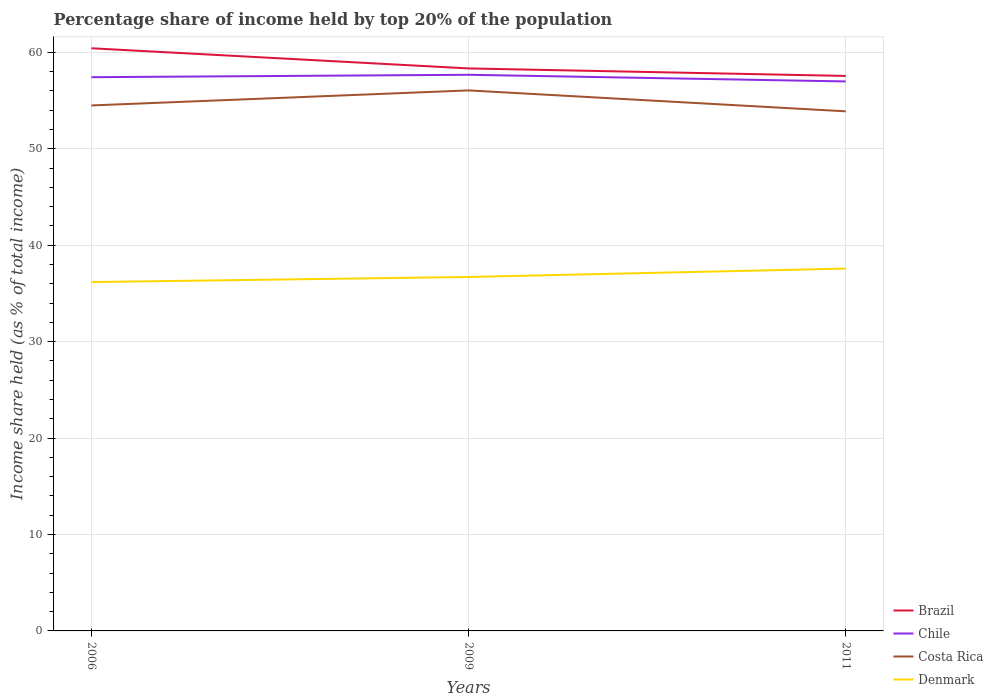How many different coloured lines are there?
Give a very brief answer. 4. Is the number of lines equal to the number of legend labels?
Offer a very short reply. Yes. Across all years, what is the maximum percentage share of income held by top 20% of the population in Chile?
Provide a short and direct response. 56.99. What is the total percentage share of income held by top 20% of the population in Brazil in the graph?
Offer a terse response. 0.78. What is the difference between the highest and the second highest percentage share of income held by top 20% of the population in Costa Rica?
Offer a terse response. 2.17. Are the values on the major ticks of Y-axis written in scientific E-notation?
Give a very brief answer. No. How many legend labels are there?
Provide a short and direct response. 4. How are the legend labels stacked?
Make the answer very short. Vertical. What is the title of the graph?
Provide a succinct answer. Percentage share of income held by top 20% of the population. Does "Macao" appear as one of the legend labels in the graph?
Keep it short and to the point. No. What is the label or title of the Y-axis?
Keep it short and to the point. Income share held (as % of total income). What is the Income share held (as % of total income) in Brazil in 2006?
Offer a very short reply. 60.43. What is the Income share held (as % of total income) in Chile in 2006?
Your response must be concise. 57.43. What is the Income share held (as % of total income) in Costa Rica in 2006?
Your response must be concise. 54.5. What is the Income share held (as % of total income) of Denmark in 2006?
Give a very brief answer. 36.18. What is the Income share held (as % of total income) in Brazil in 2009?
Provide a succinct answer. 58.34. What is the Income share held (as % of total income) in Chile in 2009?
Your response must be concise. 57.68. What is the Income share held (as % of total income) of Costa Rica in 2009?
Offer a very short reply. 56.06. What is the Income share held (as % of total income) in Denmark in 2009?
Give a very brief answer. 36.71. What is the Income share held (as % of total income) in Brazil in 2011?
Give a very brief answer. 57.56. What is the Income share held (as % of total income) in Chile in 2011?
Keep it short and to the point. 56.99. What is the Income share held (as % of total income) of Costa Rica in 2011?
Provide a succinct answer. 53.89. What is the Income share held (as % of total income) of Denmark in 2011?
Your response must be concise. 37.58. Across all years, what is the maximum Income share held (as % of total income) of Brazil?
Keep it short and to the point. 60.43. Across all years, what is the maximum Income share held (as % of total income) in Chile?
Offer a very short reply. 57.68. Across all years, what is the maximum Income share held (as % of total income) in Costa Rica?
Provide a short and direct response. 56.06. Across all years, what is the maximum Income share held (as % of total income) in Denmark?
Give a very brief answer. 37.58. Across all years, what is the minimum Income share held (as % of total income) of Brazil?
Ensure brevity in your answer.  57.56. Across all years, what is the minimum Income share held (as % of total income) in Chile?
Offer a very short reply. 56.99. Across all years, what is the minimum Income share held (as % of total income) of Costa Rica?
Your response must be concise. 53.89. Across all years, what is the minimum Income share held (as % of total income) of Denmark?
Provide a short and direct response. 36.18. What is the total Income share held (as % of total income) of Brazil in the graph?
Provide a succinct answer. 176.33. What is the total Income share held (as % of total income) of Chile in the graph?
Offer a terse response. 172.1. What is the total Income share held (as % of total income) of Costa Rica in the graph?
Your answer should be very brief. 164.45. What is the total Income share held (as % of total income) in Denmark in the graph?
Ensure brevity in your answer.  110.47. What is the difference between the Income share held (as % of total income) in Brazil in 2006 and that in 2009?
Provide a short and direct response. 2.09. What is the difference between the Income share held (as % of total income) of Costa Rica in 2006 and that in 2009?
Offer a very short reply. -1.56. What is the difference between the Income share held (as % of total income) of Denmark in 2006 and that in 2009?
Your answer should be compact. -0.53. What is the difference between the Income share held (as % of total income) of Brazil in 2006 and that in 2011?
Keep it short and to the point. 2.87. What is the difference between the Income share held (as % of total income) in Chile in 2006 and that in 2011?
Make the answer very short. 0.44. What is the difference between the Income share held (as % of total income) of Costa Rica in 2006 and that in 2011?
Make the answer very short. 0.61. What is the difference between the Income share held (as % of total income) of Denmark in 2006 and that in 2011?
Provide a short and direct response. -1.4. What is the difference between the Income share held (as % of total income) of Brazil in 2009 and that in 2011?
Your answer should be very brief. 0.78. What is the difference between the Income share held (as % of total income) of Chile in 2009 and that in 2011?
Offer a terse response. 0.69. What is the difference between the Income share held (as % of total income) of Costa Rica in 2009 and that in 2011?
Offer a terse response. 2.17. What is the difference between the Income share held (as % of total income) of Denmark in 2009 and that in 2011?
Make the answer very short. -0.87. What is the difference between the Income share held (as % of total income) in Brazil in 2006 and the Income share held (as % of total income) in Chile in 2009?
Make the answer very short. 2.75. What is the difference between the Income share held (as % of total income) in Brazil in 2006 and the Income share held (as % of total income) in Costa Rica in 2009?
Give a very brief answer. 4.37. What is the difference between the Income share held (as % of total income) of Brazil in 2006 and the Income share held (as % of total income) of Denmark in 2009?
Your answer should be very brief. 23.72. What is the difference between the Income share held (as % of total income) of Chile in 2006 and the Income share held (as % of total income) of Costa Rica in 2009?
Make the answer very short. 1.37. What is the difference between the Income share held (as % of total income) of Chile in 2006 and the Income share held (as % of total income) of Denmark in 2009?
Ensure brevity in your answer.  20.72. What is the difference between the Income share held (as % of total income) of Costa Rica in 2006 and the Income share held (as % of total income) of Denmark in 2009?
Provide a succinct answer. 17.79. What is the difference between the Income share held (as % of total income) in Brazil in 2006 and the Income share held (as % of total income) in Chile in 2011?
Your response must be concise. 3.44. What is the difference between the Income share held (as % of total income) in Brazil in 2006 and the Income share held (as % of total income) in Costa Rica in 2011?
Provide a short and direct response. 6.54. What is the difference between the Income share held (as % of total income) in Brazil in 2006 and the Income share held (as % of total income) in Denmark in 2011?
Your answer should be compact. 22.85. What is the difference between the Income share held (as % of total income) of Chile in 2006 and the Income share held (as % of total income) of Costa Rica in 2011?
Give a very brief answer. 3.54. What is the difference between the Income share held (as % of total income) of Chile in 2006 and the Income share held (as % of total income) of Denmark in 2011?
Provide a succinct answer. 19.85. What is the difference between the Income share held (as % of total income) in Costa Rica in 2006 and the Income share held (as % of total income) in Denmark in 2011?
Your answer should be compact. 16.92. What is the difference between the Income share held (as % of total income) of Brazil in 2009 and the Income share held (as % of total income) of Chile in 2011?
Your response must be concise. 1.35. What is the difference between the Income share held (as % of total income) in Brazil in 2009 and the Income share held (as % of total income) in Costa Rica in 2011?
Keep it short and to the point. 4.45. What is the difference between the Income share held (as % of total income) of Brazil in 2009 and the Income share held (as % of total income) of Denmark in 2011?
Your answer should be very brief. 20.76. What is the difference between the Income share held (as % of total income) of Chile in 2009 and the Income share held (as % of total income) of Costa Rica in 2011?
Your answer should be very brief. 3.79. What is the difference between the Income share held (as % of total income) in Chile in 2009 and the Income share held (as % of total income) in Denmark in 2011?
Offer a very short reply. 20.1. What is the difference between the Income share held (as % of total income) in Costa Rica in 2009 and the Income share held (as % of total income) in Denmark in 2011?
Ensure brevity in your answer.  18.48. What is the average Income share held (as % of total income) in Brazil per year?
Provide a short and direct response. 58.78. What is the average Income share held (as % of total income) of Chile per year?
Offer a terse response. 57.37. What is the average Income share held (as % of total income) in Costa Rica per year?
Ensure brevity in your answer.  54.82. What is the average Income share held (as % of total income) of Denmark per year?
Keep it short and to the point. 36.82. In the year 2006, what is the difference between the Income share held (as % of total income) of Brazil and Income share held (as % of total income) of Chile?
Your response must be concise. 3. In the year 2006, what is the difference between the Income share held (as % of total income) of Brazil and Income share held (as % of total income) of Costa Rica?
Your answer should be very brief. 5.93. In the year 2006, what is the difference between the Income share held (as % of total income) of Brazil and Income share held (as % of total income) of Denmark?
Give a very brief answer. 24.25. In the year 2006, what is the difference between the Income share held (as % of total income) of Chile and Income share held (as % of total income) of Costa Rica?
Offer a very short reply. 2.93. In the year 2006, what is the difference between the Income share held (as % of total income) of Chile and Income share held (as % of total income) of Denmark?
Your answer should be compact. 21.25. In the year 2006, what is the difference between the Income share held (as % of total income) of Costa Rica and Income share held (as % of total income) of Denmark?
Offer a very short reply. 18.32. In the year 2009, what is the difference between the Income share held (as % of total income) in Brazil and Income share held (as % of total income) in Chile?
Your response must be concise. 0.66. In the year 2009, what is the difference between the Income share held (as % of total income) of Brazil and Income share held (as % of total income) of Costa Rica?
Your answer should be compact. 2.28. In the year 2009, what is the difference between the Income share held (as % of total income) of Brazil and Income share held (as % of total income) of Denmark?
Keep it short and to the point. 21.63. In the year 2009, what is the difference between the Income share held (as % of total income) of Chile and Income share held (as % of total income) of Costa Rica?
Give a very brief answer. 1.62. In the year 2009, what is the difference between the Income share held (as % of total income) of Chile and Income share held (as % of total income) of Denmark?
Your answer should be very brief. 20.97. In the year 2009, what is the difference between the Income share held (as % of total income) in Costa Rica and Income share held (as % of total income) in Denmark?
Offer a terse response. 19.35. In the year 2011, what is the difference between the Income share held (as % of total income) in Brazil and Income share held (as % of total income) in Chile?
Your response must be concise. 0.57. In the year 2011, what is the difference between the Income share held (as % of total income) in Brazil and Income share held (as % of total income) in Costa Rica?
Provide a succinct answer. 3.67. In the year 2011, what is the difference between the Income share held (as % of total income) of Brazil and Income share held (as % of total income) of Denmark?
Make the answer very short. 19.98. In the year 2011, what is the difference between the Income share held (as % of total income) in Chile and Income share held (as % of total income) in Costa Rica?
Provide a short and direct response. 3.1. In the year 2011, what is the difference between the Income share held (as % of total income) in Chile and Income share held (as % of total income) in Denmark?
Keep it short and to the point. 19.41. In the year 2011, what is the difference between the Income share held (as % of total income) in Costa Rica and Income share held (as % of total income) in Denmark?
Make the answer very short. 16.31. What is the ratio of the Income share held (as % of total income) in Brazil in 2006 to that in 2009?
Your response must be concise. 1.04. What is the ratio of the Income share held (as % of total income) in Chile in 2006 to that in 2009?
Offer a very short reply. 1. What is the ratio of the Income share held (as % of total income) of Costa Rica in 2006 to that in 2009?
Ensure brevity in your answer.  0.97. What is the ratio of the Income share held (as % of total income) in Denmark in 2006 to that in 2009?
Give a very brief answer. 0.99. What is the ratio of the Income share held (as % of total income) in Brazil in 2006 to that in 2011?
Your answer should be compact. 1.05. What is the ratio of the Income share held (as % of total income) of Chile in 2006 to that in 2011?
Offer a terse response. 1.01. What is the ratio of the Income share held (as % of total income) in Costa Rica in 2006 to that in 2011?
Provide a succinct answer. 1.01. What is the ratio of the Income share held (as % of total income) in Denmark in 2006 to that in 2011?
Make the answer very short. 0.96. What is the ratio of the Income share held (as % of total income) in Brazil in 2009 to that in 2011?
Your answer should be very brief. 1.01. What is the ratio of the Income share held (as % of total income) of Chile in 2009 to that in 2011?
Provide a succinct answer. 1.01. What is the ratio of the Income share held (as % of total income) of Costa Rica in 2009 to that in 2011?
Offer a very short reply. 1.04. What is the ratio of the Income share held (as % of total income) of Denmark in 2009 to that in 2011?
Provide a succinct answer. 0.98. What is the difference between the highest and the second highest Income share held (as % of total income) in Brazil?
Your answer should be very brief. 2.09. What is the difference between the highest and the second highest Income share held (as % of total income) of Costa Rica?
Give a very brief answer. 1.56. What is the difference between the highest and the second highest Income share held (as % of total income) of Denmark?
Keep it short and to the point. 0.87. What is the difference between the highest and the lowest Income share held (as % of total income) of Brazil?
Provide a short and direct response. 2.87. What is the difference between the highest and the lowest Income share held (as % of total income) in Chile?
Ensure brevity in your answer.  0.69. What is the difference between the highest and the lowest Income share held (as % of total income) in Costa Rica?
Provide a short and direct response. 2.17. What is the difference between the highest and the lowest Income share held (as % of total income) of Denmark?
Your answer should be very brief. 1.4. 